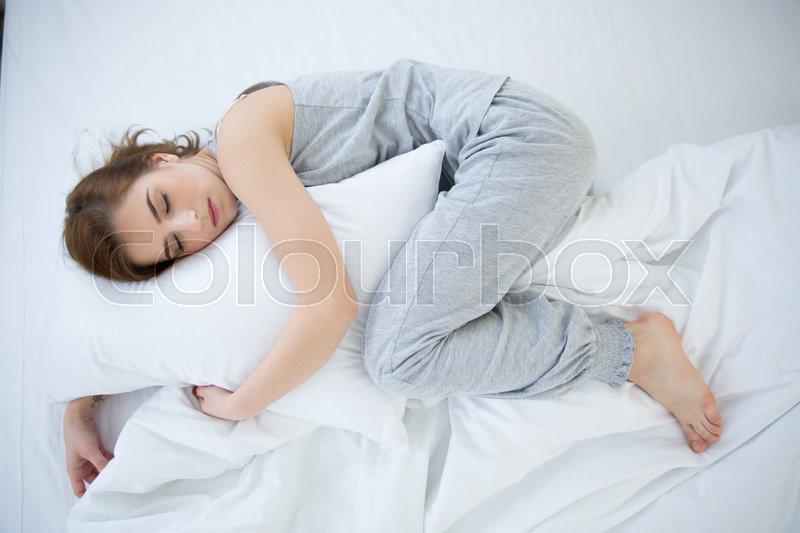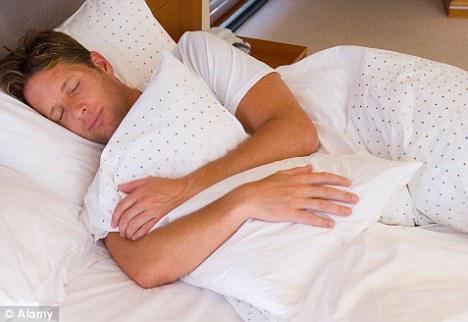The first image is the image on the left, the second image is the image on the right. Considering the images on both sides, is "There are three people." valid? Answer yes or no. No. 